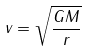Convert formula to latex. <formula><loc_0><loc_0><loc_500><loc_500>v = \sqrt { \frac { G M } { r } }</formula> 